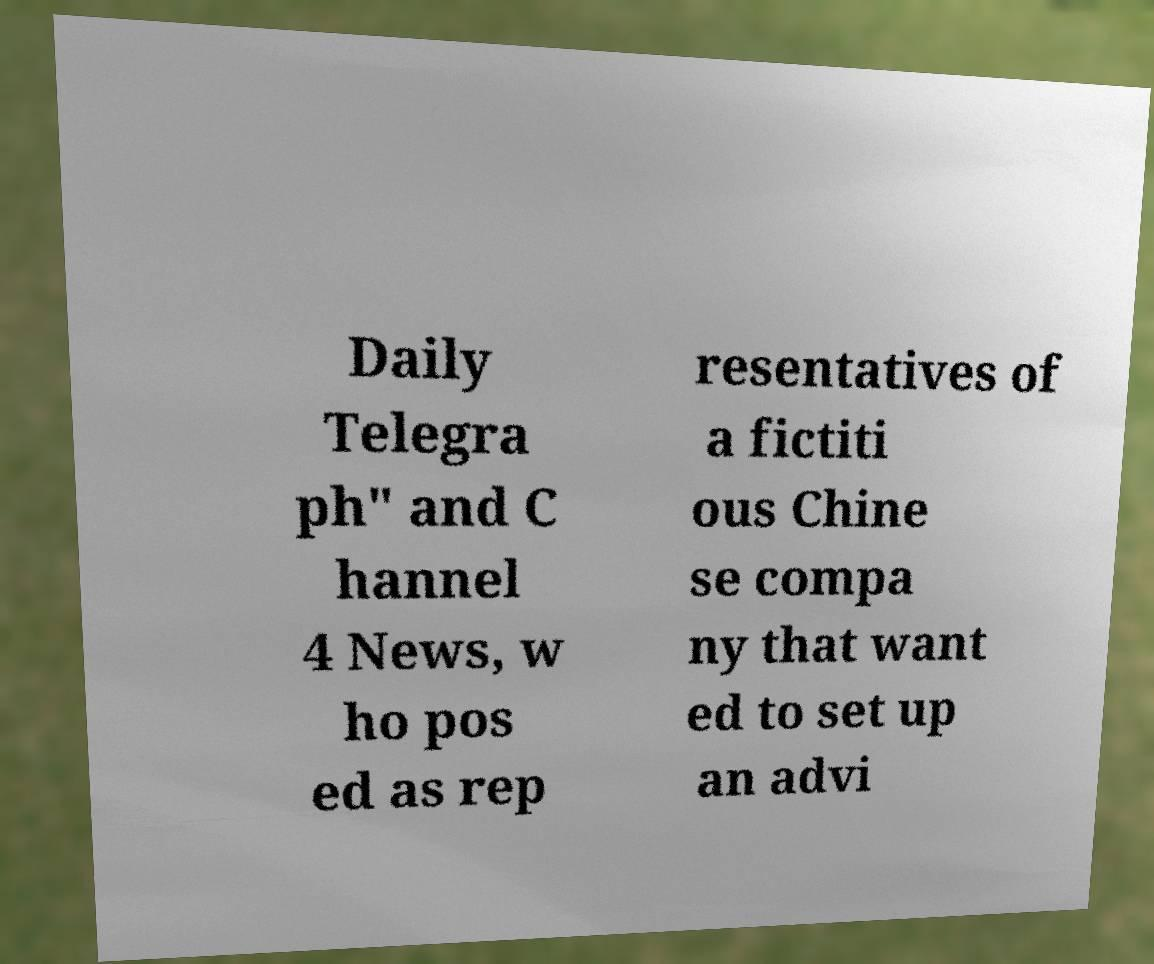Can you read and provide the text displayed in the image?This photo seems to have some interesting text. Can you extract and type it out for me? Daily Telegra ph" and C hannel 4 News, w ho pos ed as rep resentatives of a fictiti ous Chine se compa ny that want ed to set up an advi 